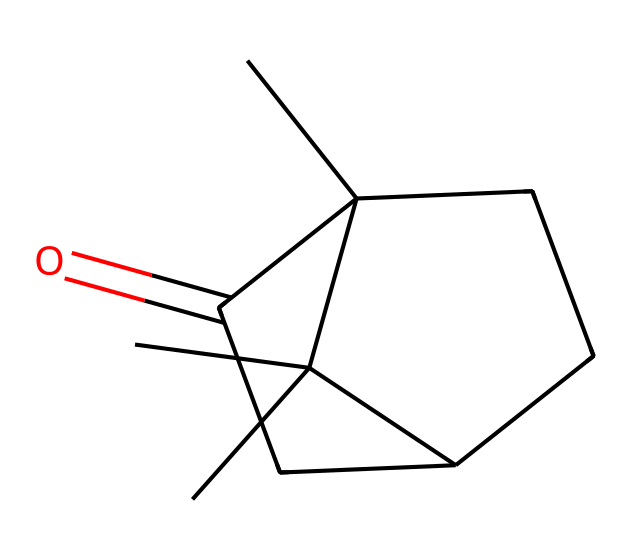What is the total number of carbon atoms in this molecule? By examining the SMILES representation, we can count the carbon atoms. There are 10 carbon atoms represented in the structure.
Answer: 10 How many rings are present in this compound? The structure includes two interconnected carbon rings, which can be deduced from the cyclic nature indicated in the SMILES.
Answer: 2 What functional group is present in camphor? Analyzing the SMILES structure, there is a carbonyl group (C=O) which identifies the presence of a ketone functional group.
Answer: ketone What is the degree of saturation in this compound? The degree of saturation can be calculated from the total number of rings and pi bonds. Here, we note the cyclic structure and the carbonyl, which adds to the saturation count, resulting in a degree of saturation of 3.
Answer: 3 How many hydrogen atoms are there in camphor? By utilizing the molecular formula derived from the SMILES, which corresponds to C10H16O, we find there are 16 hydrogen atoms in this compound.
Answer: 16 Is camphor a saturated or unsaturated compound? Since camphor contains a carbonyl and is cyclic, it does not have as many hydrogen atoms as a saturated compound. Thus, it is identified as unsaturated.
Answer: unsaturated Does camphor exhibit chirality? The structure includes a specific arrangement of the carbon atoms, where one of them (the asymmetric carbon) leads to optical isomerism. Hence, camphor is chiral.
Answer: chiral 